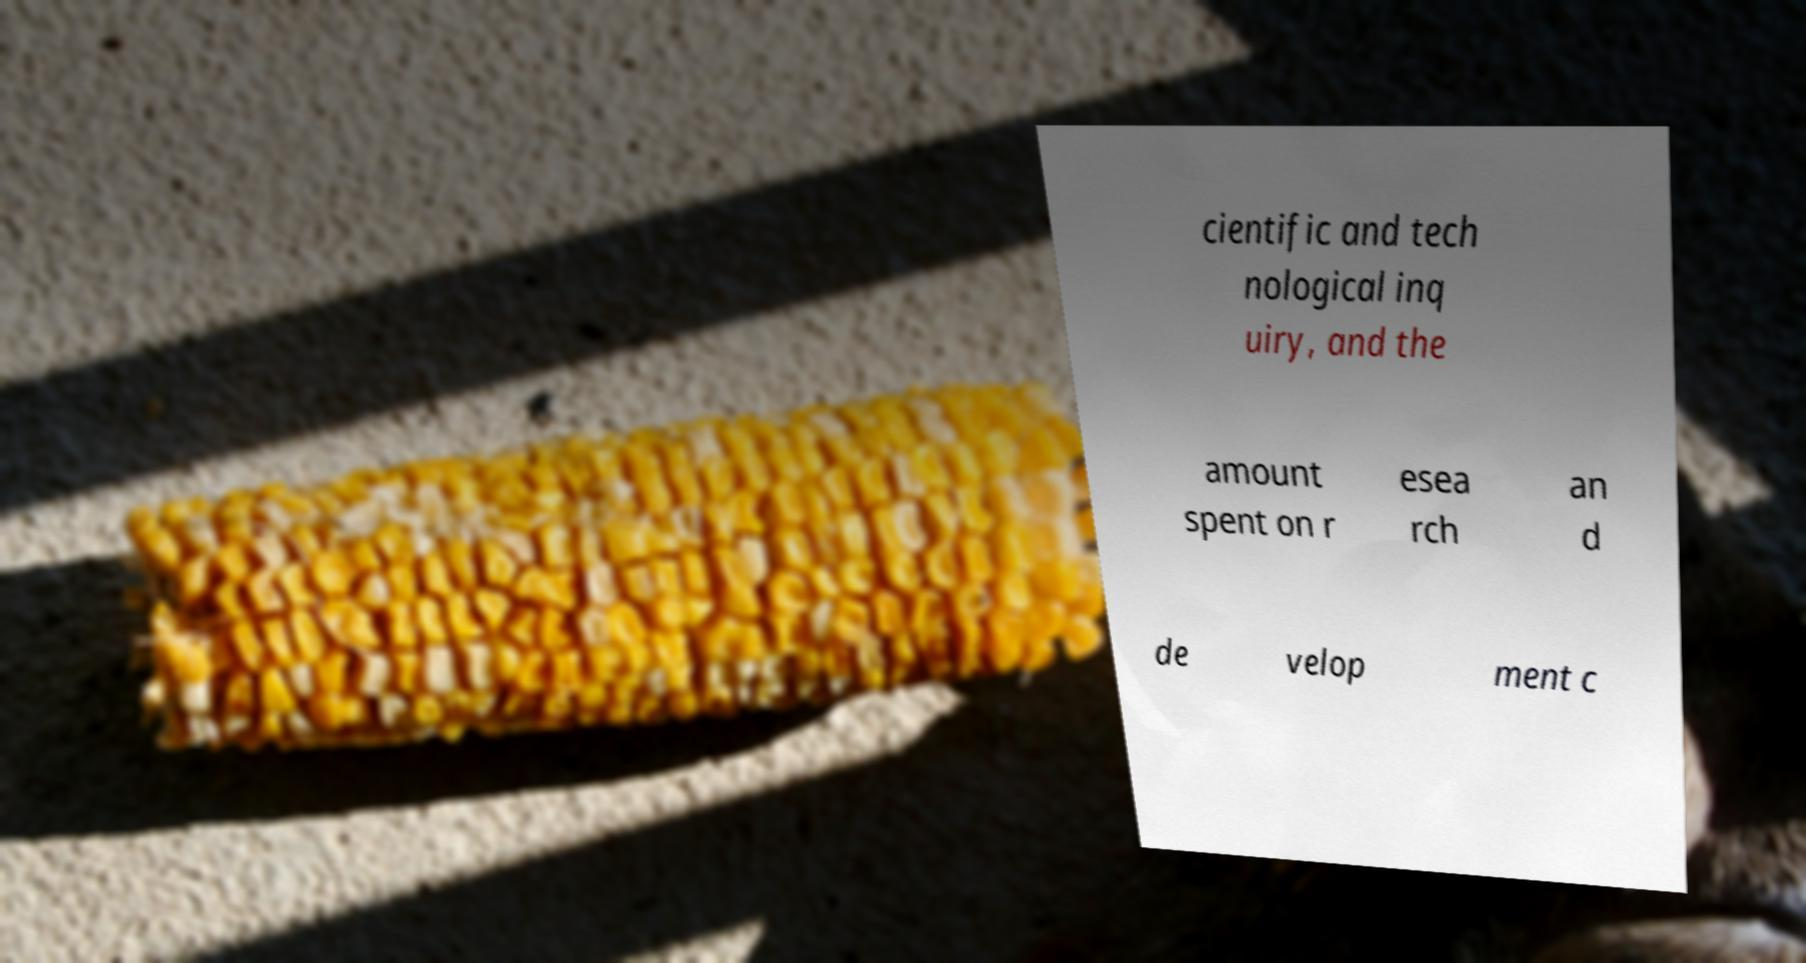For documentation purposes, I need the text within this image transcribed. Could you provide that? cientific and tech nological inq uiry, and the amount spent on r esea rch an d de velop ment c 